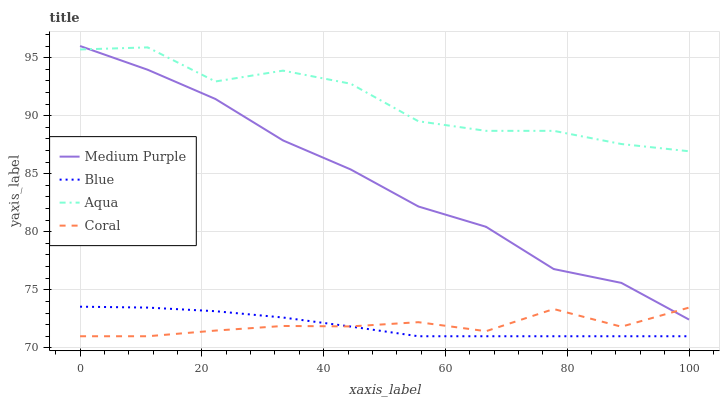Does Coral have the minimum area under the curve?
Answer yes or no. Yes. Does Aqua have the maximum area under the curve?
Answer yes or no. Yes. Does Blue have the minimum area under the curve?
Answer yes or no. No. Does Blue have the maximum area under the curve?
Answer yes or no. No. Is Blue the smoothest?
Answer yes or no. Yes. Is Aqua the roughest?
Answer yes or no. Yes. Is Coral the smoothest?
Answer yes or no. No. Is Coral the roughest?
Answer yes or no. No. Does Aqua have the lowest value?
Answer yes or no. No. Does Medium Purple have the highest value?
Answer yes or no. Yes. Does Blue have the highest value?
Answer yes or no. No. Is Blue less than Medium Purple?
Answer yes or no. Yes. Is Medium Purple greater than Blue?
Answer yes or no. Yes. Does Blue intersect Coral?
Answer yes or no. Yes. Is Blue less than Coral?
Answer yes or no. No. Is Blue greater than Coral?
Answer yes or no. No. Does Blue intersect Medium Purple?
Answer yes or no. No. 